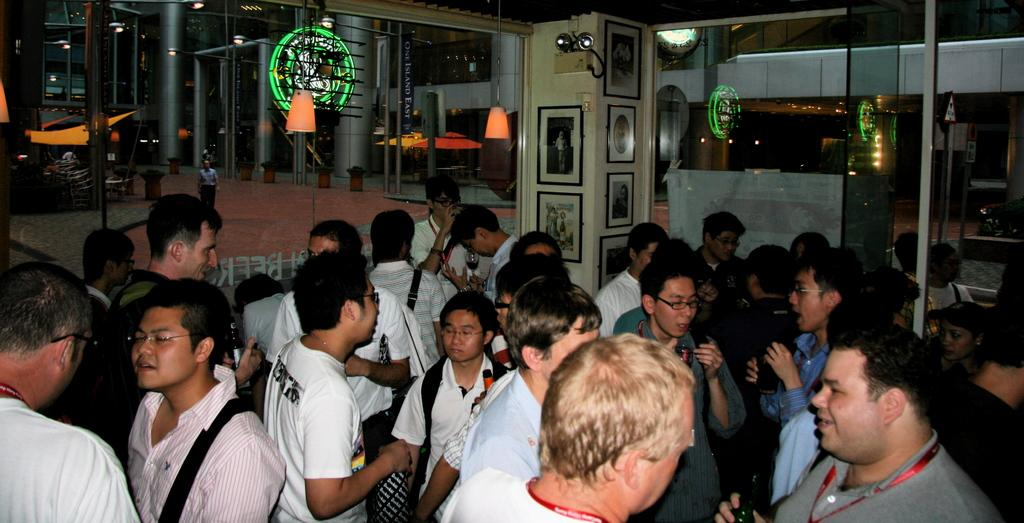What can be seen at the bottom of the image? There are persons standing at the bottom of the image. What type of doors are visible at the top of the image? There are glass doors at the top of the image. How many dogs are present in the image? There are no dogs present in the image. What type of linen is draped over the glass doors in the image? There is no linen present in the image, and the glass doors are not draped with any fabric. 